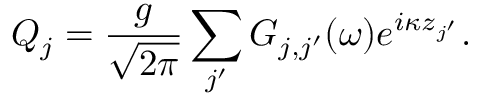<formula> <loc_0><loc_0><loc_500><loc_500>Q _ { j } = \frac { g } { \sqrt { 2 \pi } } \sum _ { j ^ { \prime } } { G _ { j , j ^ { \prime } } ( \omega ) e ^ { i \kappa z _ { j ^ { \prime } } } } .</formula> 